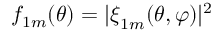<formula> <loc_0><loc_0><loc_500><loc_500>f _ { 1 m } ( \theta ) = | \xi _ { 1 m } ( \theta , \varphi ) | ^ { 2 }</formula> 